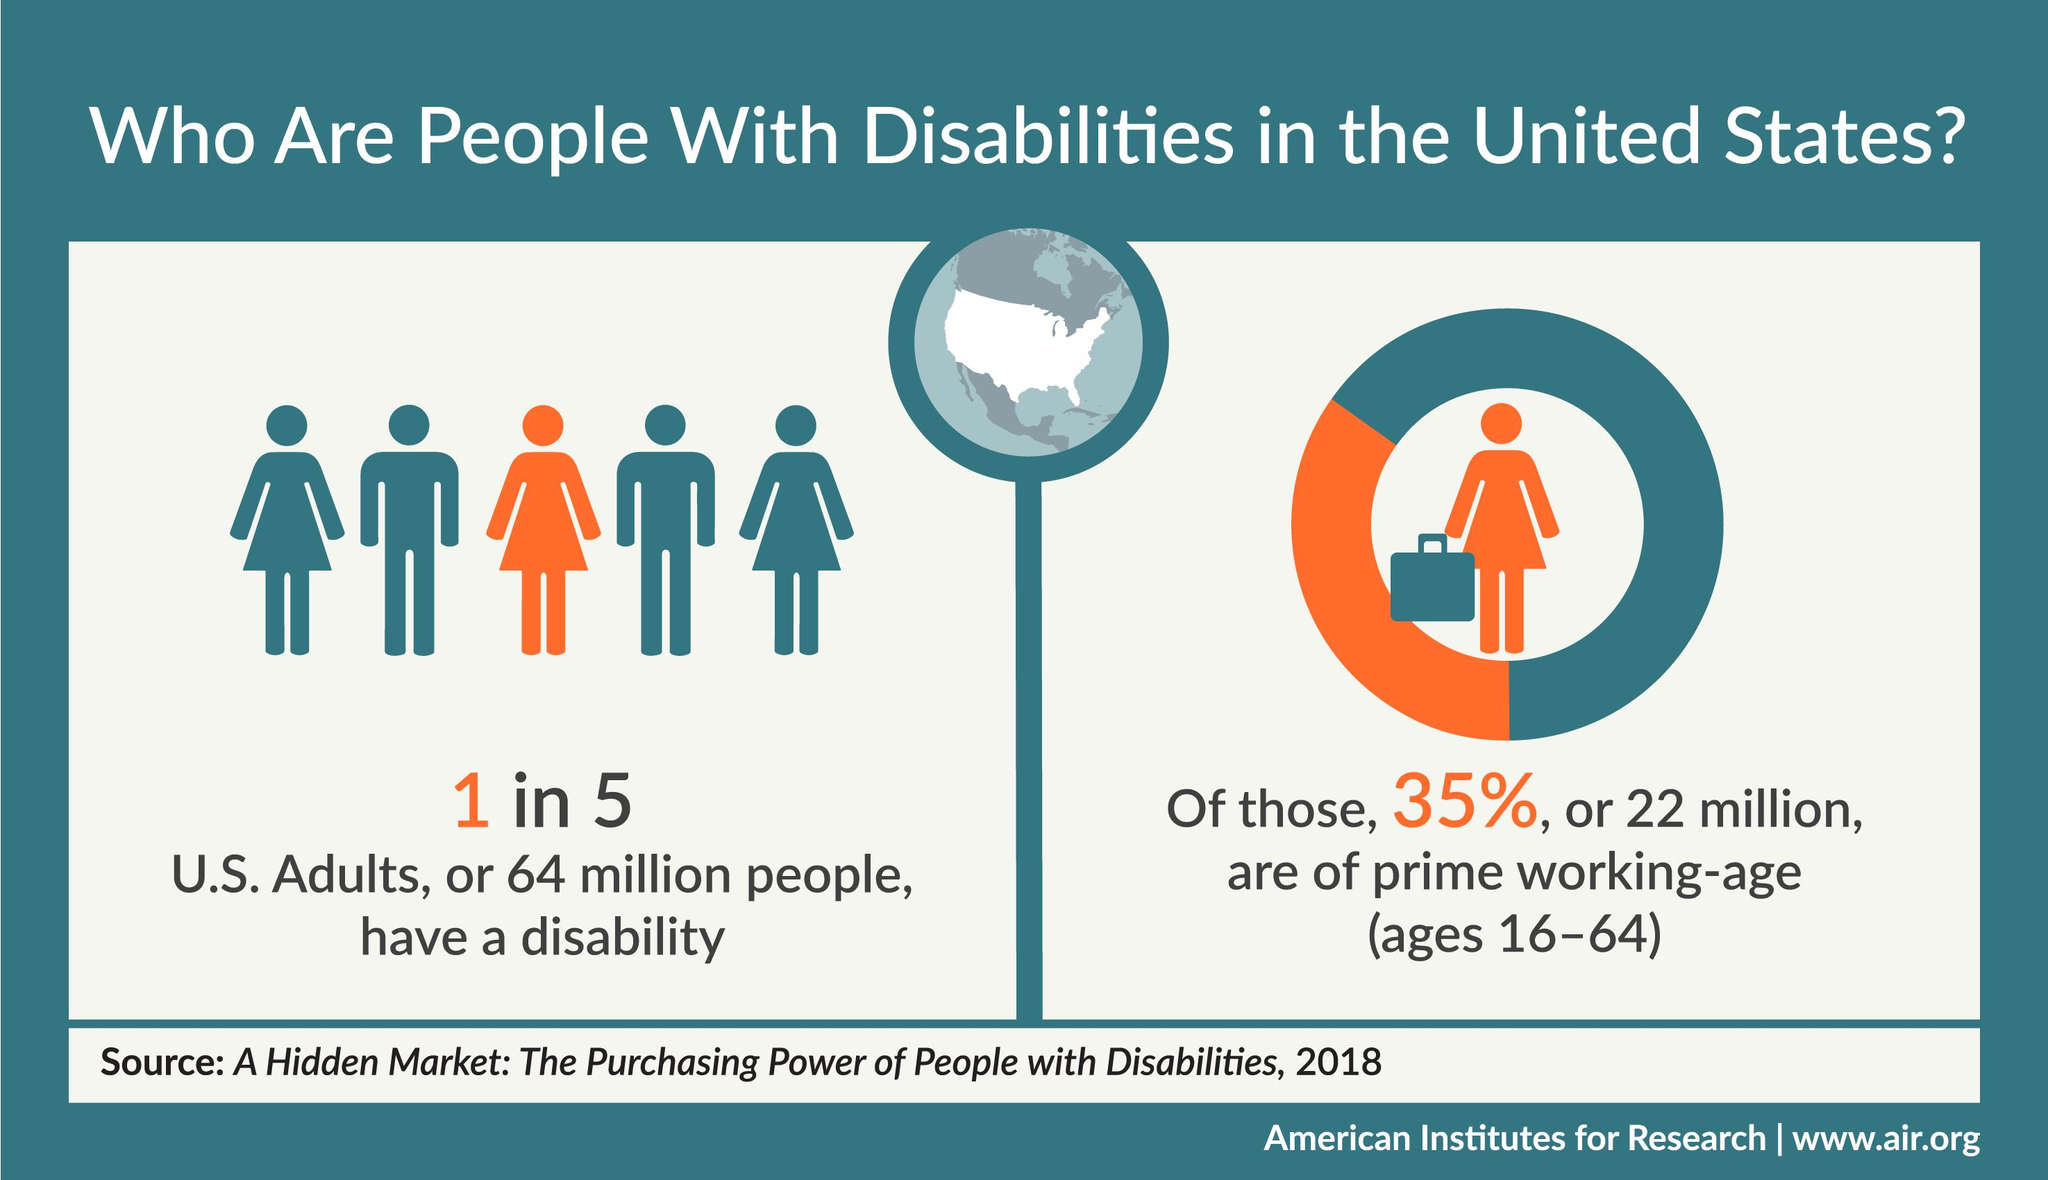Outline some significant characteristics in this image. Approximately 65% of disabled adults are not in the prime working age. According to a recent study, approximately 42 million disabled adults in the United States are not in the prime working age group. 